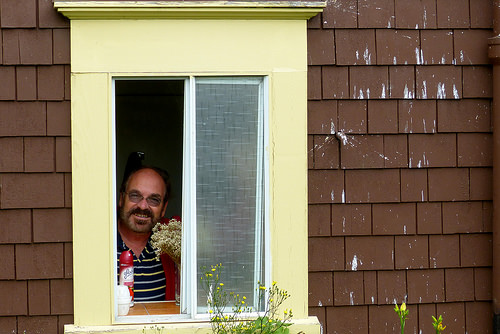<image>
Can you confirm if the plant is behind the window? Yes. From this viewpoint, the plant is positioned behind the window, with the window partially or fully occluding the plant. Is there a flowers to the right of the shirt? Yes. From this viewpoint, the flowers is positioned to the right side relative to the shirt. Is the man in front of the window? No. The man is not in front of the window. The spatial positioning shows a different relationship between these objects. Is there a man in front of the house? No. The man is not in front of the house. The spatial positioning shows a different relationship between these objects. 